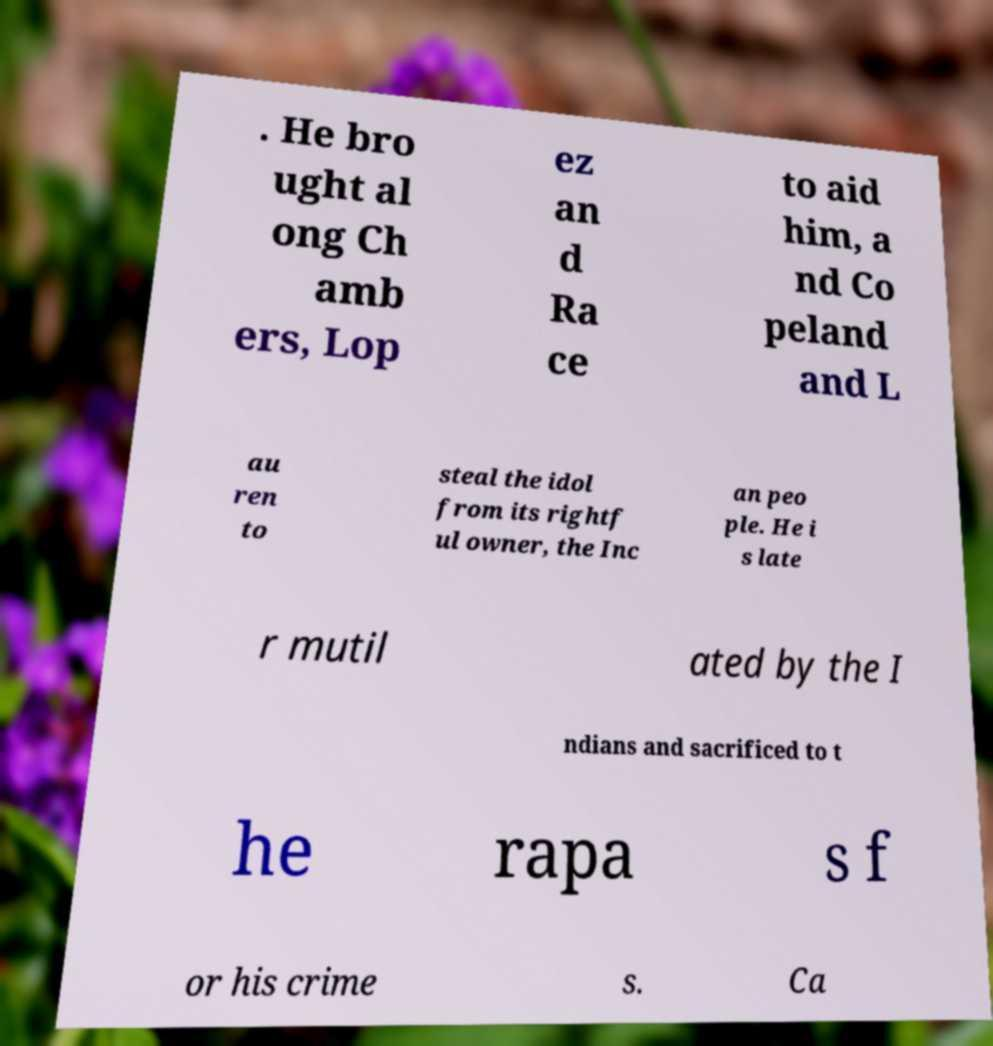Please identify and transcribe the text found in this image. . He bro ught al ong Ch amb ers, Lop ez an d Ra ce to aid him, a nd Co peland and L au ren to steal the idol from its rightf ul owner, the Inc an peo ple. He i s late r mutil ated by the I ndians and sacrificed to t he rapa s f or his crime s. Ca 